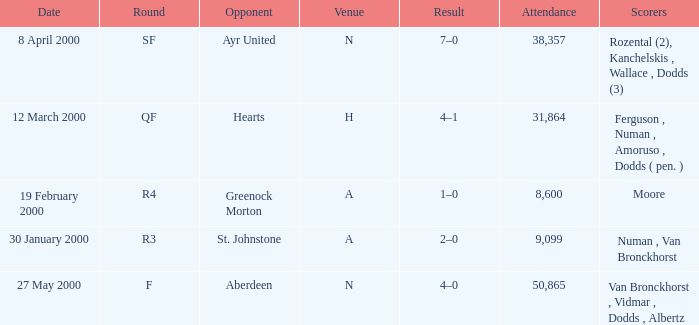Who was in a with opponent St. Johnstone? Numan , Van Bronckhorst. 